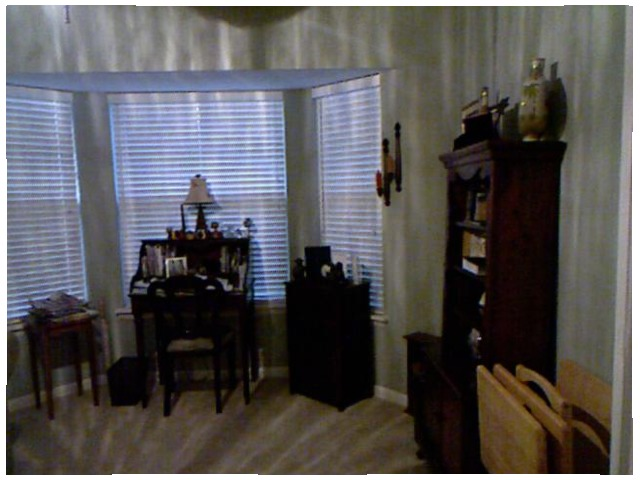<image>
Can you confirm if the candles is on the table? No. The candles is not positioned on the table. They may be near each other, but the candles is not supported by or resting on top of the table. 